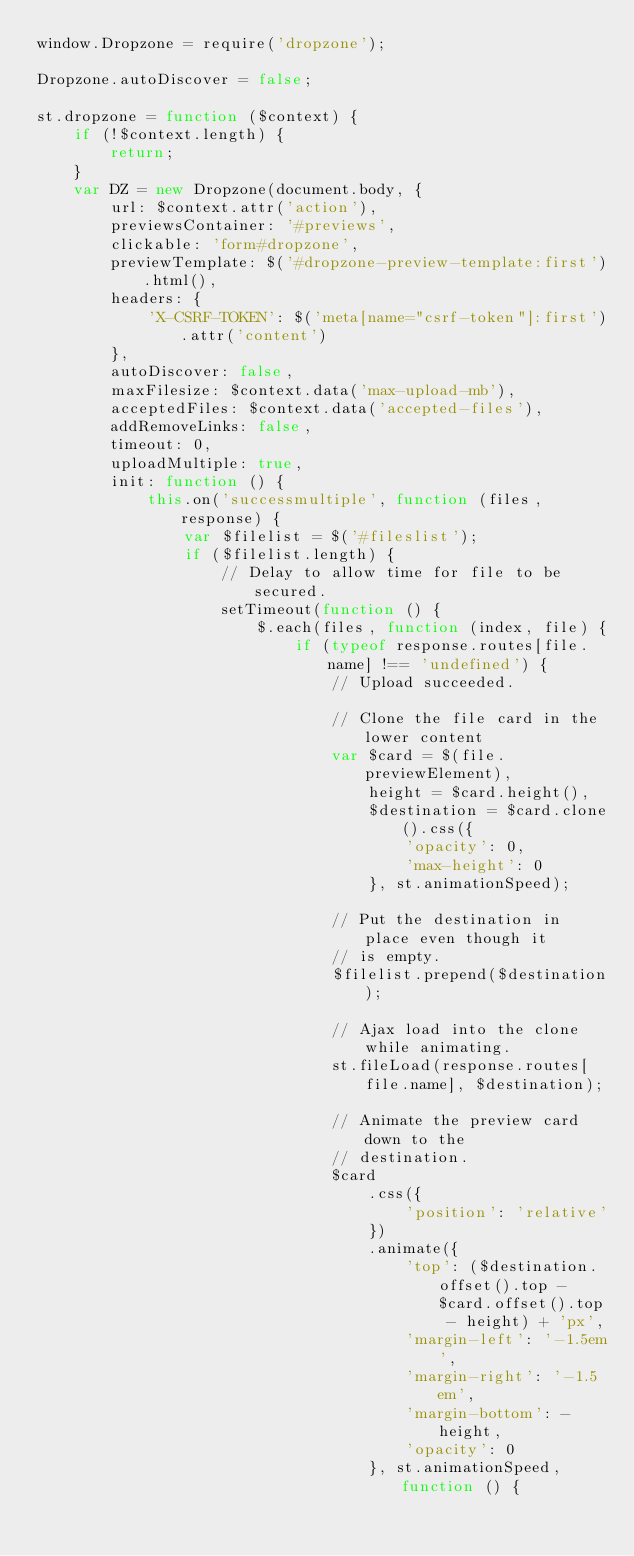Convert code to text. <code><loc_0><loc_0><loc_500><loc_500><_JavaScript_>window.Dropzone = require('dropzone');

Dropzone.autoDiscover = false;

st.dropzone = function ($context) {
    if (!$context.length) {
        return;
    }
    var DZ = new Dropzone(document.body, {
        url: $context.attr('action'),
        previewsContainer: '#previews',
        clickable: 'form#dropzone',
        previewTemplate: $('#dropzone-preview-template:first').html(),
        headers: {
            'X-CSRF-TOKEN': $('meta[name="csrf-token"]:first').attr('content')
        },
        autoDiscover: false,
        maxFilesize: $context.data('max-upload-mb'),
        acceptedFiles: $context.data('accepted-files'),
        addRemoveLinks: false,
        timeout: 0,
        uploadMultiple: true,
        init: function () {
            this.on('successmultiple', function (files, response) {
                var $filelist = $('#fileslist');
                if ($filelist.length) {
                    // Delay to allow time for file to be secured.
                    setTimeout(function () {
                        $.each(files, function (index, file) {
                            if (typeof response.routes[file.name] !== 'undefined') {
                                // Upload succeeded.

                                // Clone the file card in the lower content
                                var $card = $(file.previewElement),
                                    height = $card.height(),
                                    $destination = $card.clone().css({
                                        'opacity': 0,
                                        'max-height': 0
                                    }, st.animationSpeed);

                                // Put the destination in place even though it
                                // is empty.
                                $filelist.prepend($destination);

                                // Ajax load into the clone while animating.
                                st.fileLoad(response.routes[file.name], $destination);

                                // Animate the preview card down to the
                                // destination.
                                $card
                                    .css({
                                        'position': 'relative'
                                    })
                                    .animate({
                                        'top': ($destination.offset().top - $card.offset().top - height) + 'px',
                                        'margin-left': '-1.5em',
                                        'margin-right': '-1.5em',
                                        'margin-bottom': -height,
                                        'opacity': 0
                                    }, st.animationSpeed, function () {</code> 